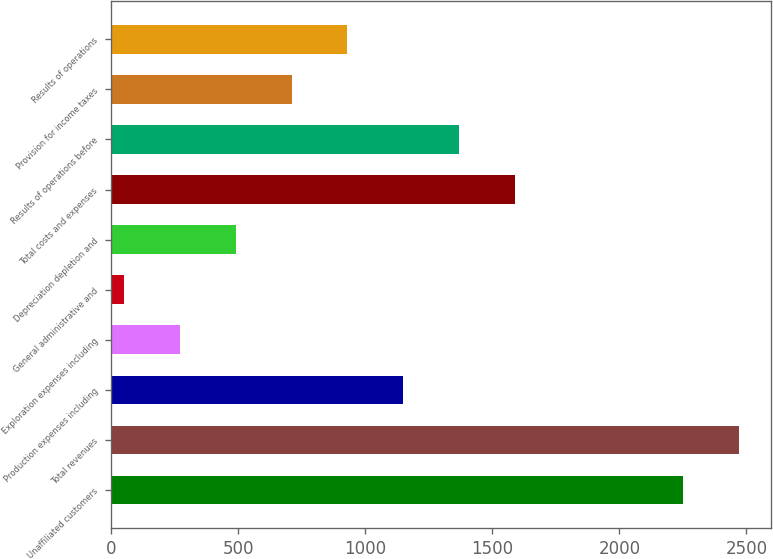Convert chart to OTSL. <chart><loc_0><loc_0><loc_500><loc_500><bar_chart><fcel>Unaffiliated customers<fcel>Total revenues<fcel>Production expenses including<fcel>Exploration expenses including<fcel>General administrative and<fcel>Depreciation depletion and<fcel>Total costs and expenses<fcel>Results of operations before<fcel>Provision for income taxes<fcel>Results of operations<nl><fcel>2251<fcel>2471.3<fcel>1149.5<fcel>268.3<fcel>48<fcel>488.6<fcel>1590.1<fcel>1369.8<fcel>708.9<fcel>929.2<nl></chart> 